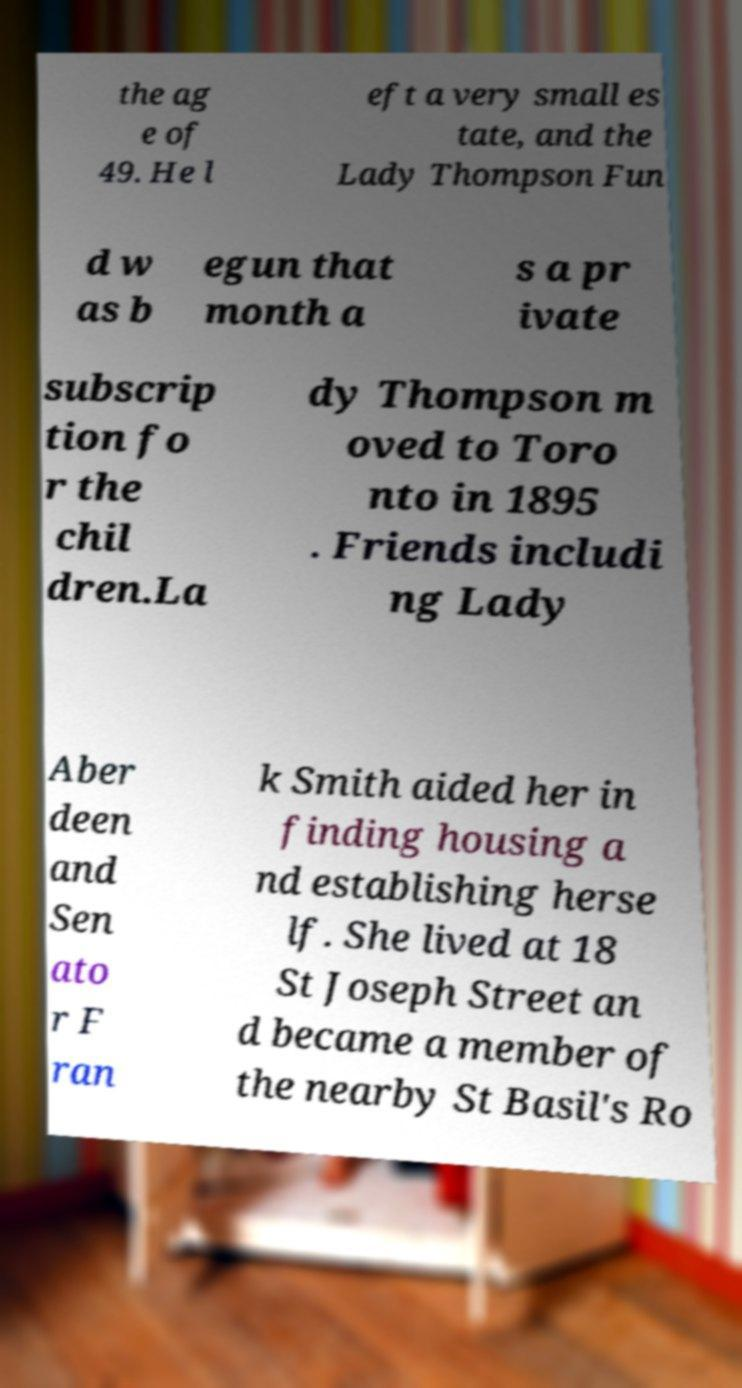Could you assist in decoding the text presented in this image and type it out clearly? the ag e of 49. He l eft a very small es tate, and the Lady Thompson Fun d w as b egun that month a s a pr ivate subscrip tion fo r the chil dren.La dy Thompson m oved to Toro nto in 1895 . Friends includi ng Lady Aber deen and Sen ato r F ran k Smith aided her in finding housing a nd establishing herse lf. She lived at 18 St Joseph Street an d became a member of the nearby St Basil's Ro 